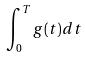Convert formula to latex. <formula><loc_0><loc_0><loc_500><loc_500>\int _ { 0 } ^ { T } g ( t ) d t</formula> 